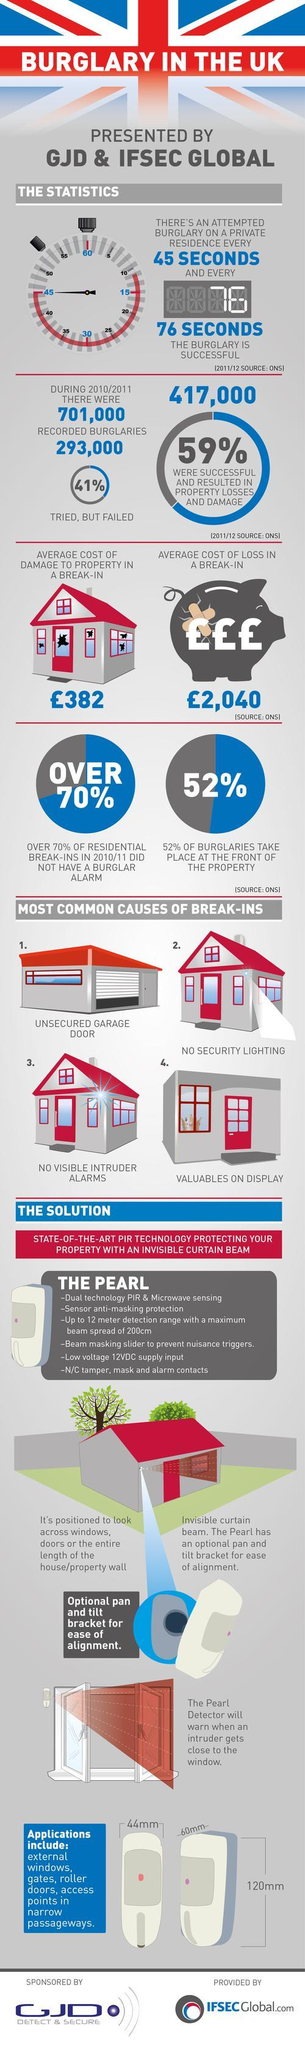Draw attention to some important aspects in this diagram. During the 2010/2011 time period, a significant percentage of burglaries in the UK failed, with 41% of attempted burglaries unsuccessful. The average cost of a break-in in the UK is approximately £2,040, according to recent statistics. During the 2010/2011 fiscal year, there were approximately 417,000 successful burglaries in the United Kingdom that resulted in property losses and damage. According to statistics, 52% of burglaries in the UK occur at the front of the property. 